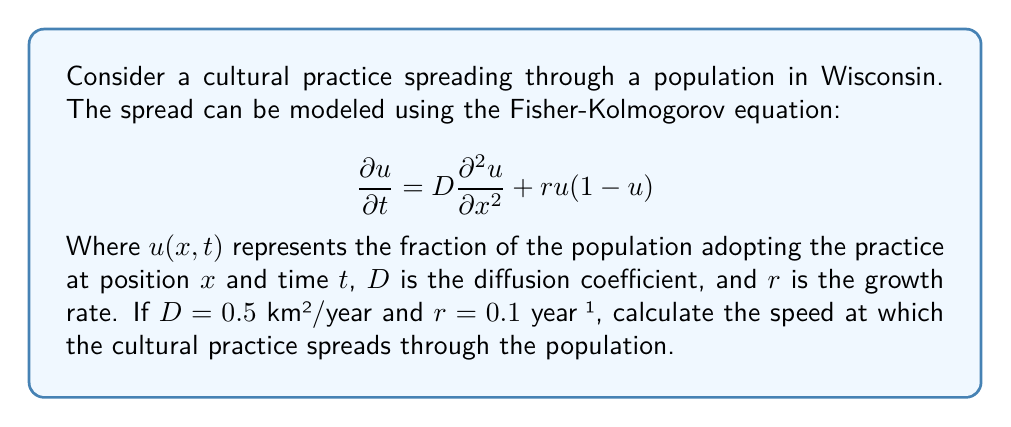Show me your answer to this math problem. To solve this problem, we'll use the formula for the speed of propagation derived from the Fisher-Kolmogorov equation:

1) The speed of propagation for the Fisher-Kolmogorov equation is given by:

   $$c = 2\sqrt{Dr}$$

2) We're given:
   $D = 0.5$ km²/year
   $r = 0.1$ year⁻¹

3) Let's substitute these values into the equation:

   $$c = 2\sqrt{(0.5 \text{ km}^2/\text{year})(0.1 \text{ year}^{-1})}$$

4) Simplify inside the square root:

   $$c = 2\sqrt{0.05 \text{ km}^2/\text{year}^2}$$

5) Calculate the square root:

   $$c = 2(0.2236 \text{ km}/\text{year})$$

6) Multiply:

   $$c = 0.4472 \text{ km}/\text{year}$$

This result represents the speed at which the cultural practice spreads through the population in Wisconsin.
Answer: $0.4472 \text{ km}/\text{year}$ 